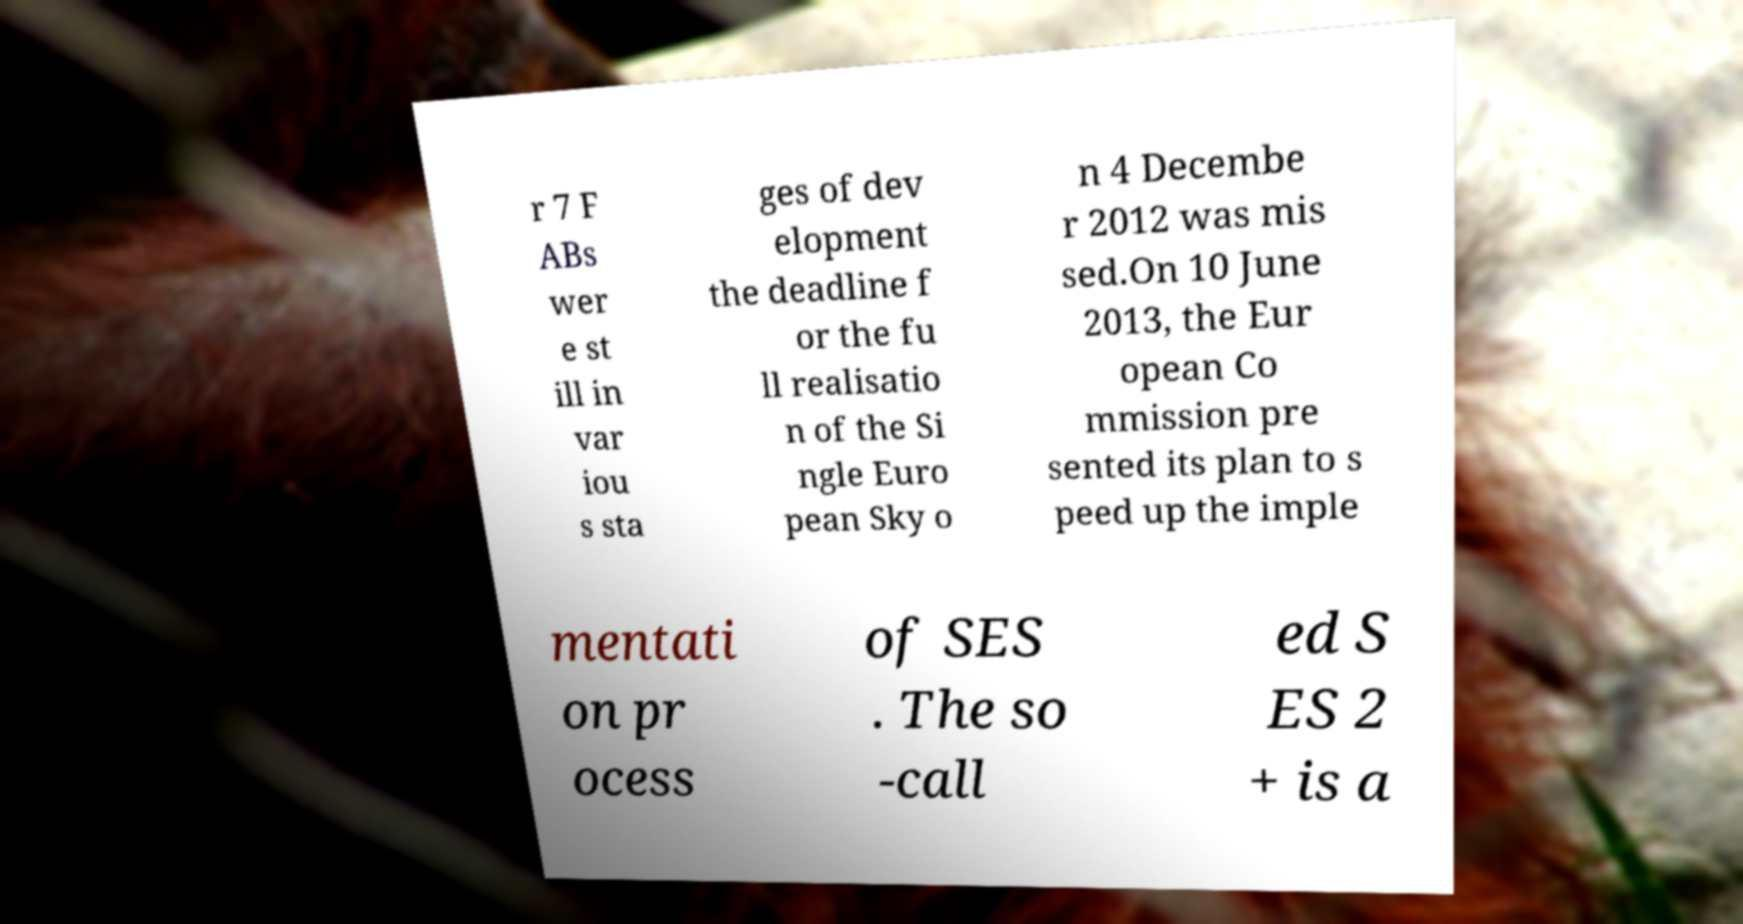What messages or text are displayed in this image? I need them in a readable, typed format. r 7 F ABs wer e st ill in var iou s sta ges of dev elopment the deadline f or the fu ll realisatio n of the Si ngle Euro pean Sky o n 4 Decembe r 2012 was mis sed.On 10 June 2013, the Eur opean Co mmission pre sented its plan to s peed up the imple mentati on pr ocess of SES . The so -call ed S ES 2 + is a 